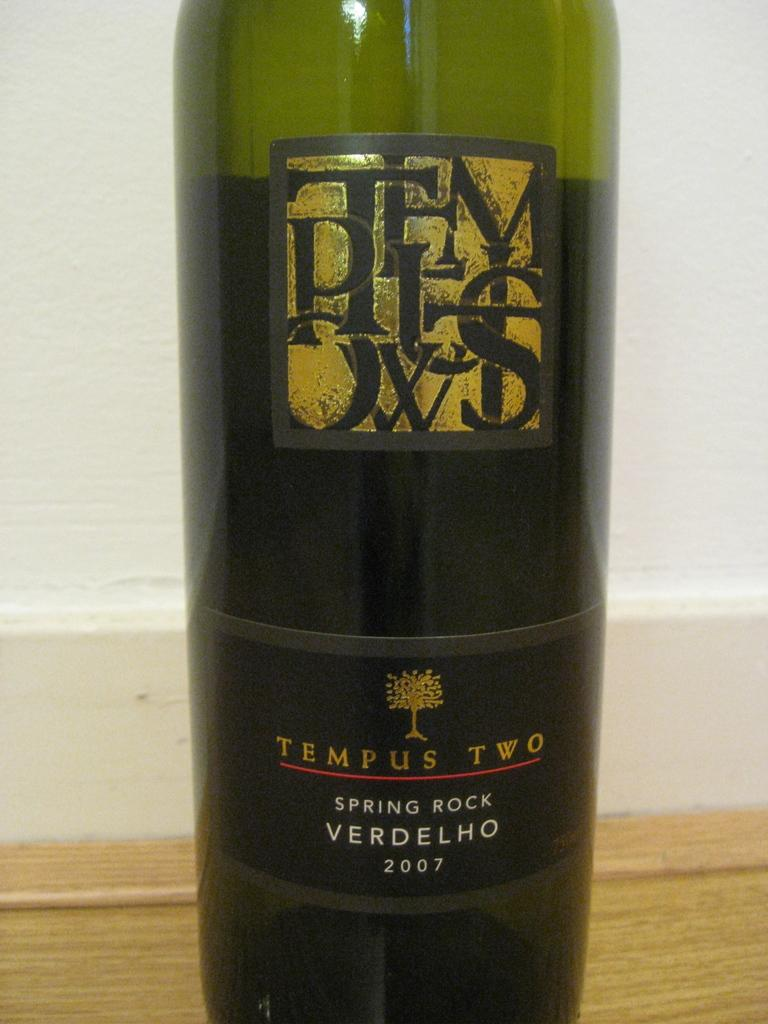<image>
Relay a brief, clear account of the picture shown. A bottle of Tempus Two wine has a tree logo on the label. 